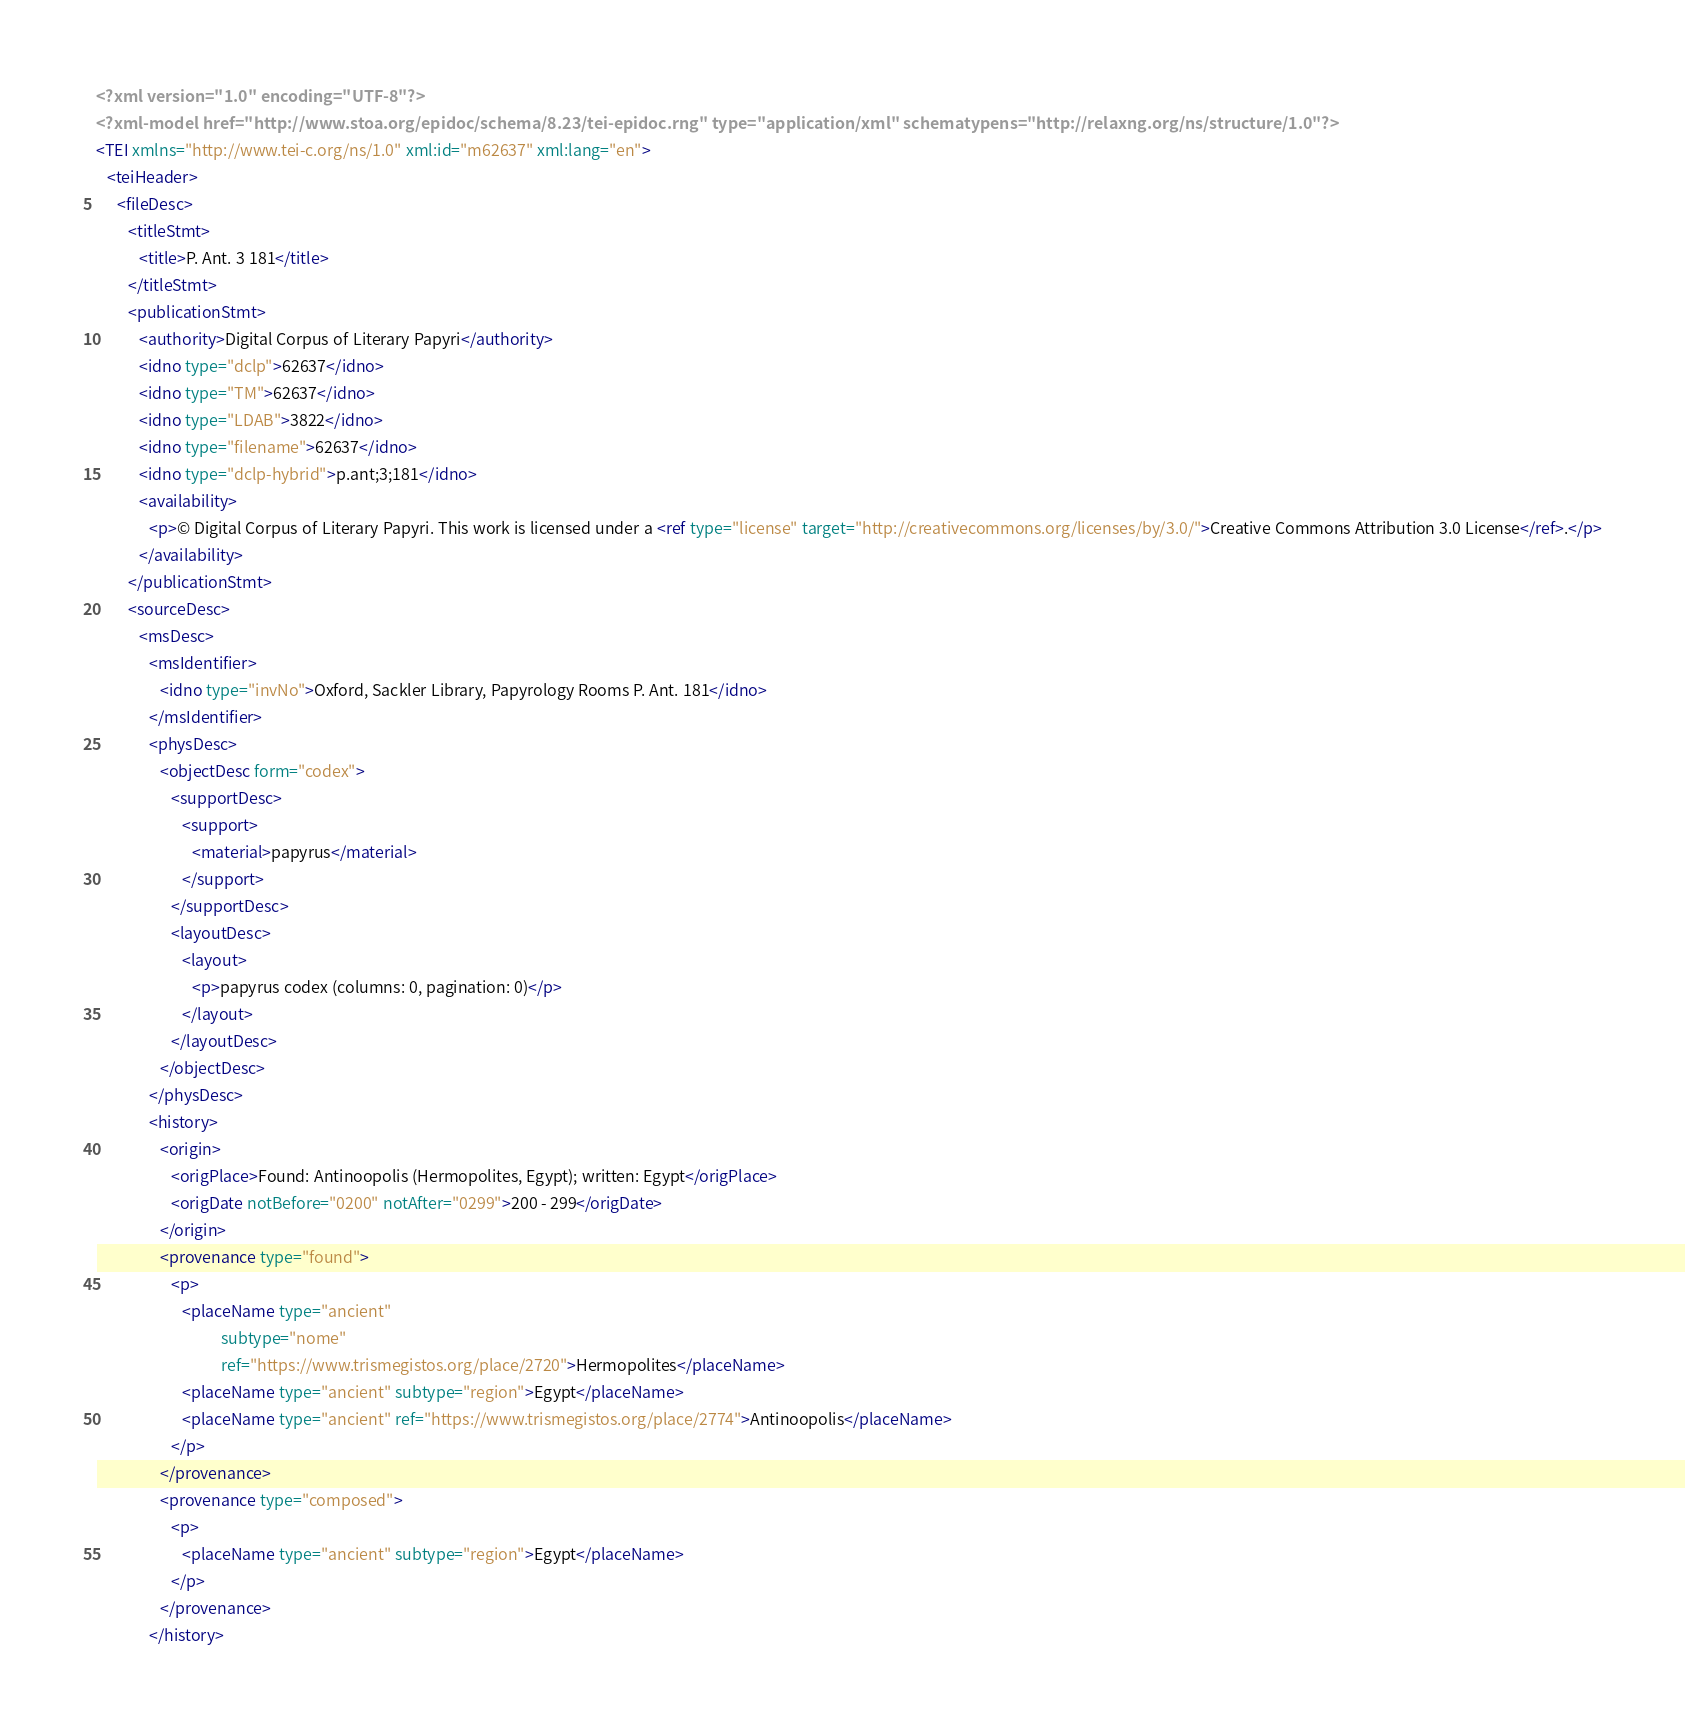Convert code to text. <code><loc_0><loc_0><loc_500><loc_500><_XML_><?xml version="1.0" encoding="UTF-8"?>
<?xml-model href="http://www.stoa.org/epidoc/schema/8.23/tei-epidoc.rng" type="application/xml" schematypens="http://relaxng.org/ns/structure/1.0"?>
<TEI xmlns="http://www.tei-c.org/ns/1.0" xml:id="m62637" xml:lang="en">
   <teiHeader>
      <fileDesc>
         <titleStmt>
            <title>P. Ant. 3 181</title>
         </titleStmt>
         <publicationStmt>
            <authority>Digital Corpus of Literary Papyri</authority>
            <idno type="dclp">62637</idno>
            <idno type="TM">62637</idno>
            <idno type="LDAB">3822</idno>
            <idno type="filename">62637</idno>
            <idno type="dclp-hybrid">p.ant;3;181</idno>
            <availability>
               <p>© Digital Corpus of Literary Papyri. This work is licensed under a <ref type="license" target="http://creativecommons.org/licenses/by/3.0/">Creative Commons Attribution 3.0 License</ref>.</p>
            </availability>
         </publicationStmt>
         <sourceDesc>
            <msDesc>
               <msIdentifier>
                  <idno type="invNo">Oxford, Sackler Library, Papyrology Rooms P. Ant. 181</idno>
               </msIdentifier>
               <physDesc>
                  <objectDesc form="codex">
                     <supportDesc>
                        <support>
                           <material>papyrus</material>
                        </support>
                     </supportDesc>
                     <layoutDesc>
                        <layout>
                           <p>papyrus codex (columns: 0, pagination: 0)</p>
                        </layout>
                     </layoutDesc>
                  </objectDesc>
               </physDesc>
               <history>
                  <origin>
                     <origPlace>Found: Antinoopolis (Hermopolites, Egypt); written: Egypt</origPlace>
                     <origDate notBefore="0200" notAfter="0299">200 - 299</origDate>
                  </origin>
                  <provenance type="found">
                     <p>
                        <placeName type="ancient"
                                   subtype="nome"
                                   ref="https://www.trismegistos.org/place/2720">Hermopolites</placeName>
                        <placeName type="ancient" subtype="region">Egypt</placeName>
                        <placeName type="ancient" ref="https://www.trismegistos.org/place/2774">Antinoopolis</placeName>
                     </p>
                  </provenance>
                  <provenance type="composed">
                     <p>
                        <placeName type="ancient" subtype="region">Egypt</placeName>
                     </p>
                  </provenance>
               </history></code> 